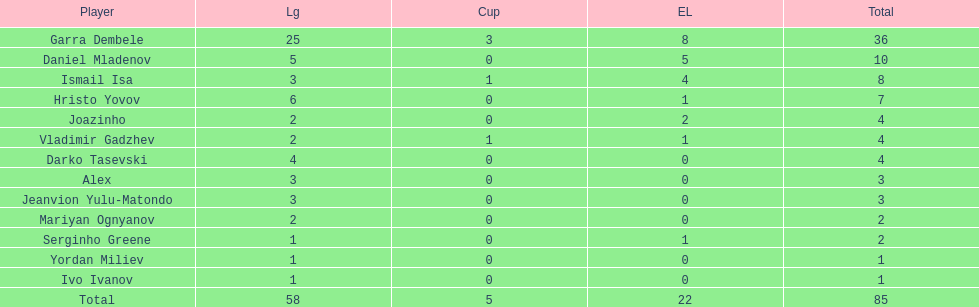Who was the top goalscorer on this team? Garra Dembele. 